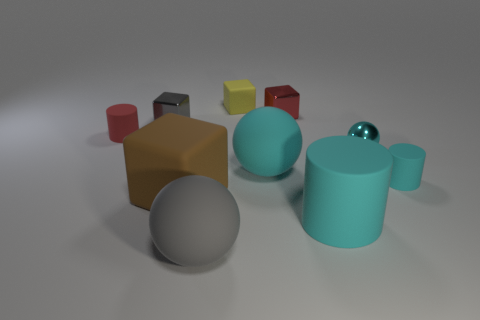What number of things are either balls or tiny red rubber things behind the gray ball?
Your response must be concise. 4. The tiny block that is both in front of the yellow rubber object and to the right of the big gray matte thing is made of what material?
Give a very brief answer. Metal. Is there any other thing that is the same shape as the brown rubber thing?
Offer a terse response. Yes. What is the color of the large cube that is the same material as the big cylinder?
Offer a very short reply. Brown. How many things are tiny cyan cylinders or brown matte cubes?
Your answer should be compact. 2. There is a red cylinder; is it the same size as the gray thing that is in front of the big cylinder?
Offer a very short reply. No. There is a cylinder that is in front of the large thing that is on the left side of the gray object in front of the small cyan matte object; what color is it?
Offer a very short reply. Cyan. The large rubber block has what color?
Offer a very short reply. Brown. Are there more tiny cyan objects on the left side of the small red rubber cylinder than large cyan things behind the metal ball?
Your response must be concise. No. Do the big brown thing and the gray thing behind the large gray rubber ball have the same shape?
Offer a very short reply. Yes. 